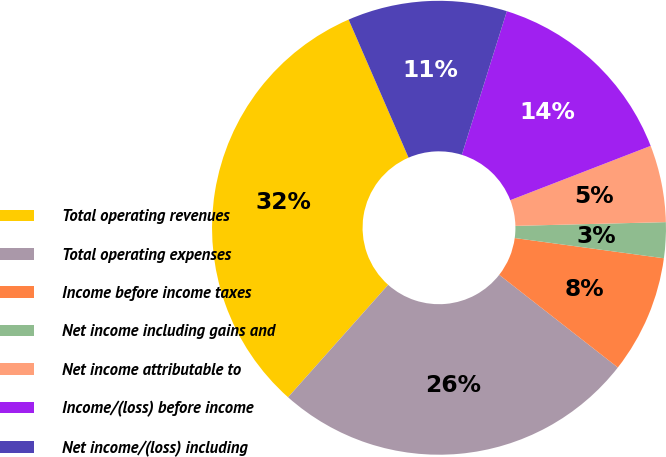Convert chart. <chart><loc_0><loc_0><loc_500><loc_500><pie_chart><fcel>Total operating revenues<fcel>Total operating expenses<fcel>Income before income taxes<fcel>Net income including gains and<fcel>Net income attributable to<fcel>Income/(loss) before income<fcel>Net income/(loss) including<nl><fcel>31.9%<fcel>26.02%<fcel>8.41%<fcel>2.54%<fcel>5.48%<fcel>14.29%<fcel>11.35%<nl></chart> 